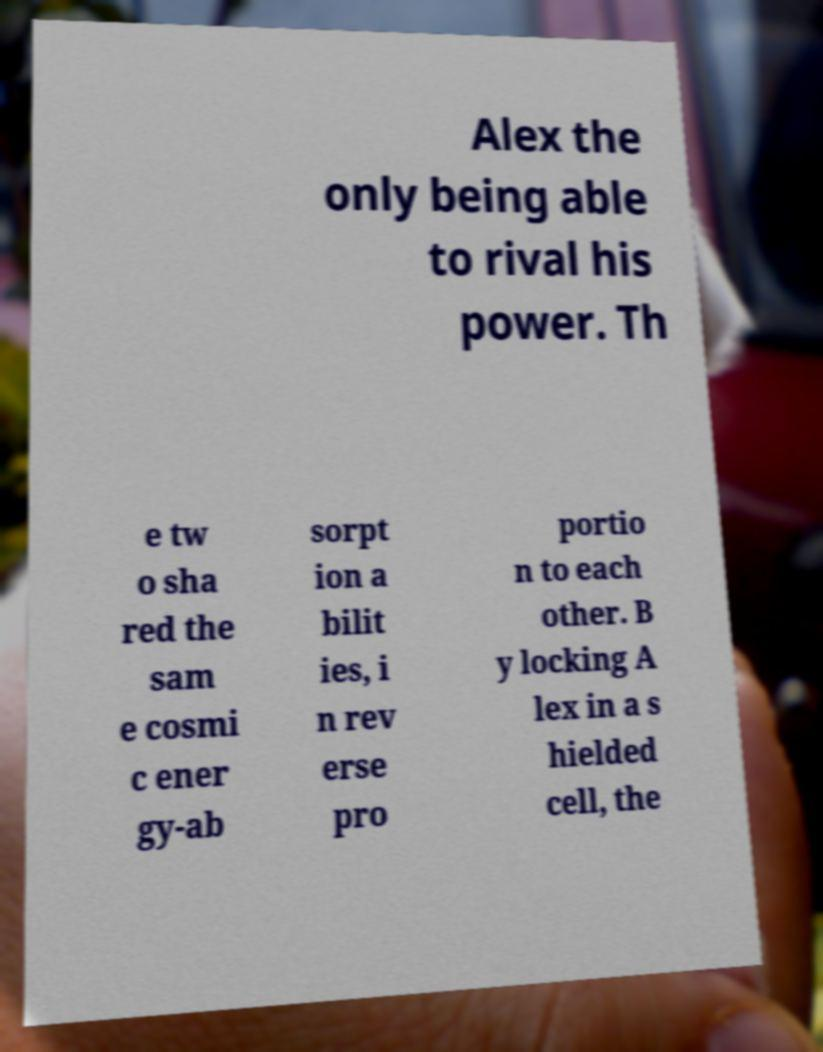Please read and relay the text visible in this image. What does it say? Alex the only being able to rival his power. Th e tw o sha red the sam e cosmi c ener gy-ab sorpt ion a bilit ies, i n rev erse pro portio n to each other. B y locking A lex in a s hielded cell, the 